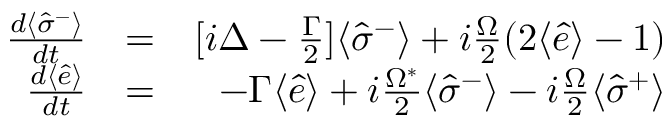Convert formula to latex. <formula><loc_0><loc_0><loc_500><loc_500>\begin{array} { r l r } { \frac { d \langle \hat { \sigma } ^ { - } \rangle } { d t } } & { = } & { [ i \Delta - \frac { \Gamma } { 2 } ] \langle \hat { \sigma } ^ { - } \rangle + i \frac { \Omega } { 2 } ( 2 \langle \hat { e } \rangle - 1 ) } \\ { \frac { d \langle \hat { e } \rangle } { d t } } & { = } & { - \Gamma \langle \hat { e } \rangle + i \frac { \Omega ^ { * } } { 2 } \langle \hat { \sigma } ^ { - } \rangle - i \frac { \Omega } { 2 } \langle \hat { \sigma } ^ { + } \rangle } \end{array}</formula> 